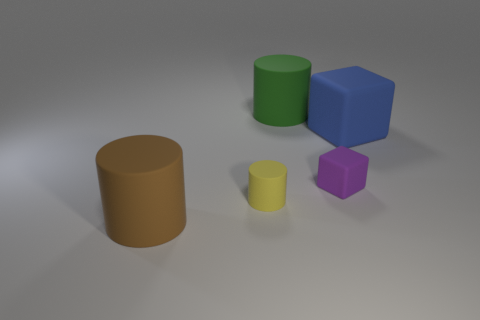What shape is the tiny yellow rubber thing? The small yellow object appears to be a cylindrical shape, akin to a miniature rubber or plastic cylinder, commonly used for various purposes such as a child's toy or an educational aid to demonstrate geometric shapes. 